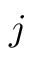<formula> <loc_0><loc_0><loc_500><loc_500>j</formula> 